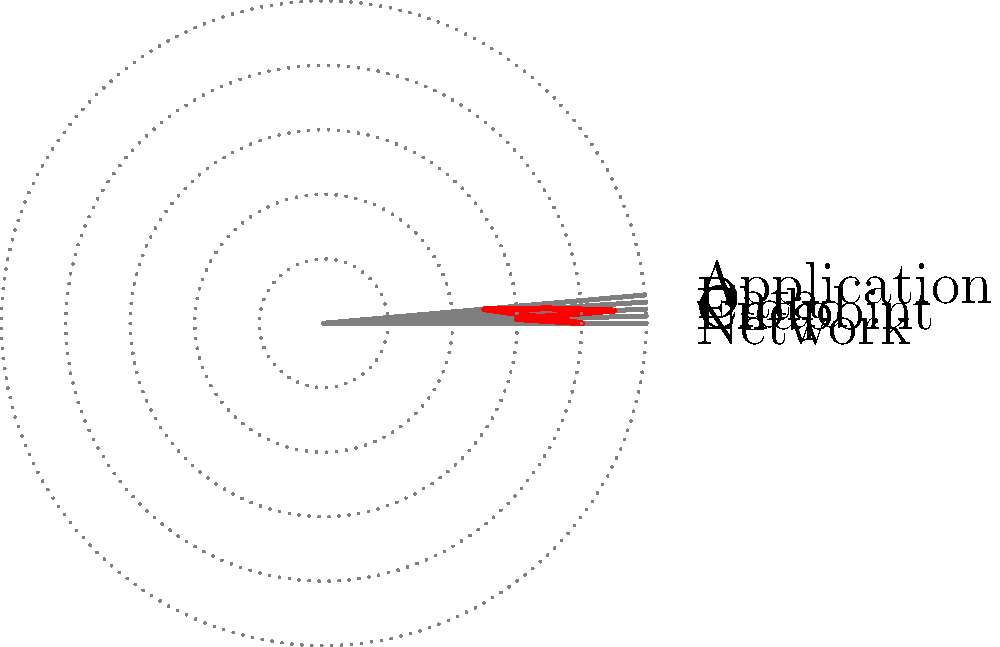In the polar radar chart representing multi-dimensional cybersecurity data, which dimension shows the highest level of security, and what is its approximate value? To determine the dimension with the highest level of security and its approximate value, we need to follow these steps:

1. Identify the dimensions represented in the chart:
   The chart shows five dimensions: Network, Endpoint, Cloud, Data, and Application.

2. Analyze the data points:
   Each dimension is represented by a point on the chart, where the distance from the center indicates the security level (higher is better).

3. Compare the data points:
   Visually inspect each data point to determine which one extends furthest from the center.

4. Identify the highest point:
   The dimension that extends furthest from the center is Cloud.

5. Estimate the value:
   The Cloud dimension appears to extend about 90% of the way to the outermost ring.

6. Conclude:
   The Cloud dimension shows the highest level of security with an approximate value of 0.9 or 90%.
Answer: Cloud, approximately 0.9 (90%) 